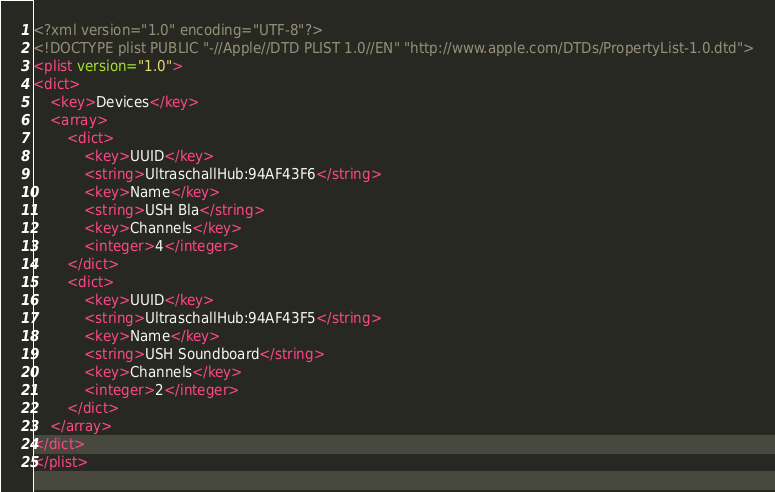<code> <loc_0><loc_0><loc_500><loc_500><_XML_><?xml version="1.0" encoding="UTF-8"?>
<!DOCTYPE plist PUBLIC "-//Apple//DTD PLIST 1.0//EN" "http://www.apple.com/DTDs/PropertyList-1.0.dtd">
<plist version="1.0">
<dict>
	<key>Devices</key>
	<array>
		<dict>
			<key>UUID</key>
			<string>UltraschallHub:94AF43F6</string>
			<key>Name</key>
			<string>USH Bla</string>
			<key>Channels</key>
			<integer>4</integer>
		</dict>
		<dict>
			<key>UUID</key>
			<string>UltraschallHub:94AF43F5</string>
			<key>Name</key>
			<string>USH Soundboard</string>
			<key>Channels</key>
			<integer>2</integer>
		</dict>
	</array>
</dict>
</plist>
</code> 